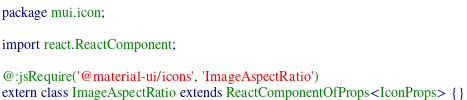Convert code to text. <code><loc_0><loc_0><loc_500><loc_500><_Haxe_>package mui.icon;

import react.ReactComponent;

@:jsRequire('@material-ui/icons', 'ImageAspectRatio')
extern class ImageAspectRatio extends ReactComponentOfProps<IconProps> {}
</code> 